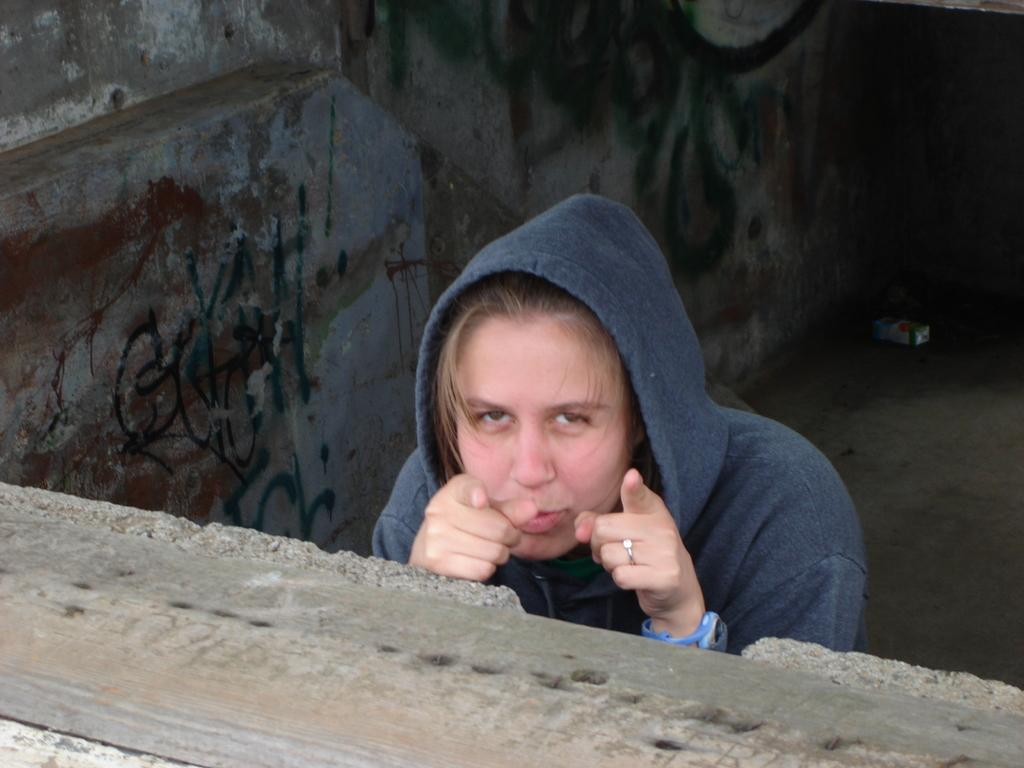Who is present in the image? There is a woman in the image. What type of clothing is the woman wearing? The woman is wearing a hoodie. Are there any accessories visible on the woman? Yes, the woman is wearing a ring and a watch. What type of yarn is the woman knitting in the image? There is no yarn or knitting activity present in the image. Can you hear a bell ringing in the image? There is no bell or sound present in the image. 